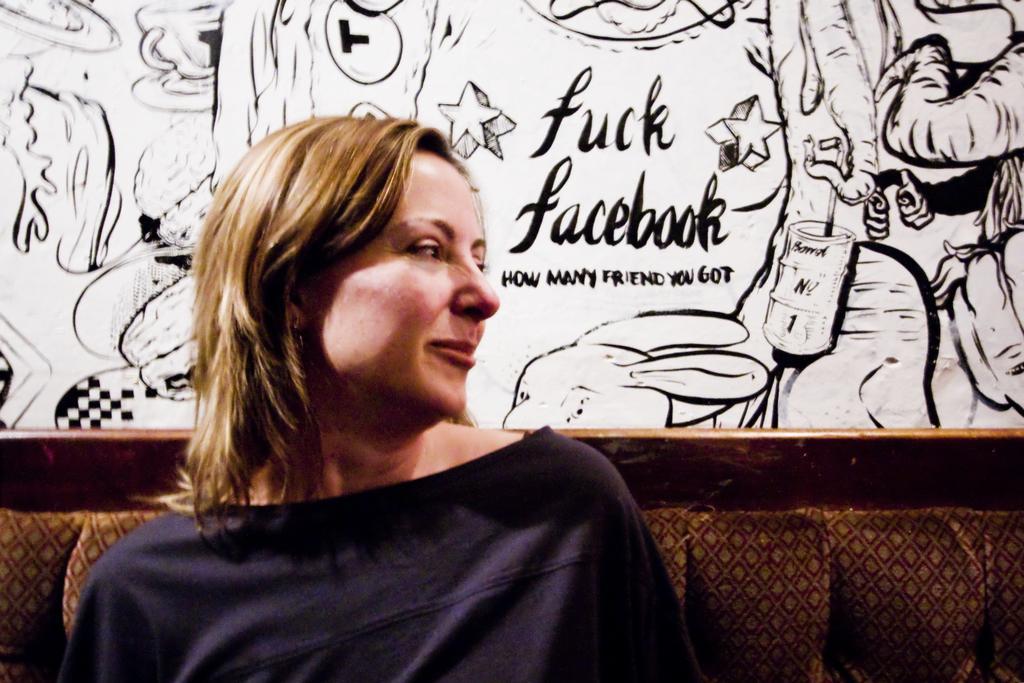Could you give a brief overview of what you see in this image? In this image in the front there is a woman sitting and smiling. In the background there is a painting on the wall and there is some text written on it and in the center there is a sofa. 